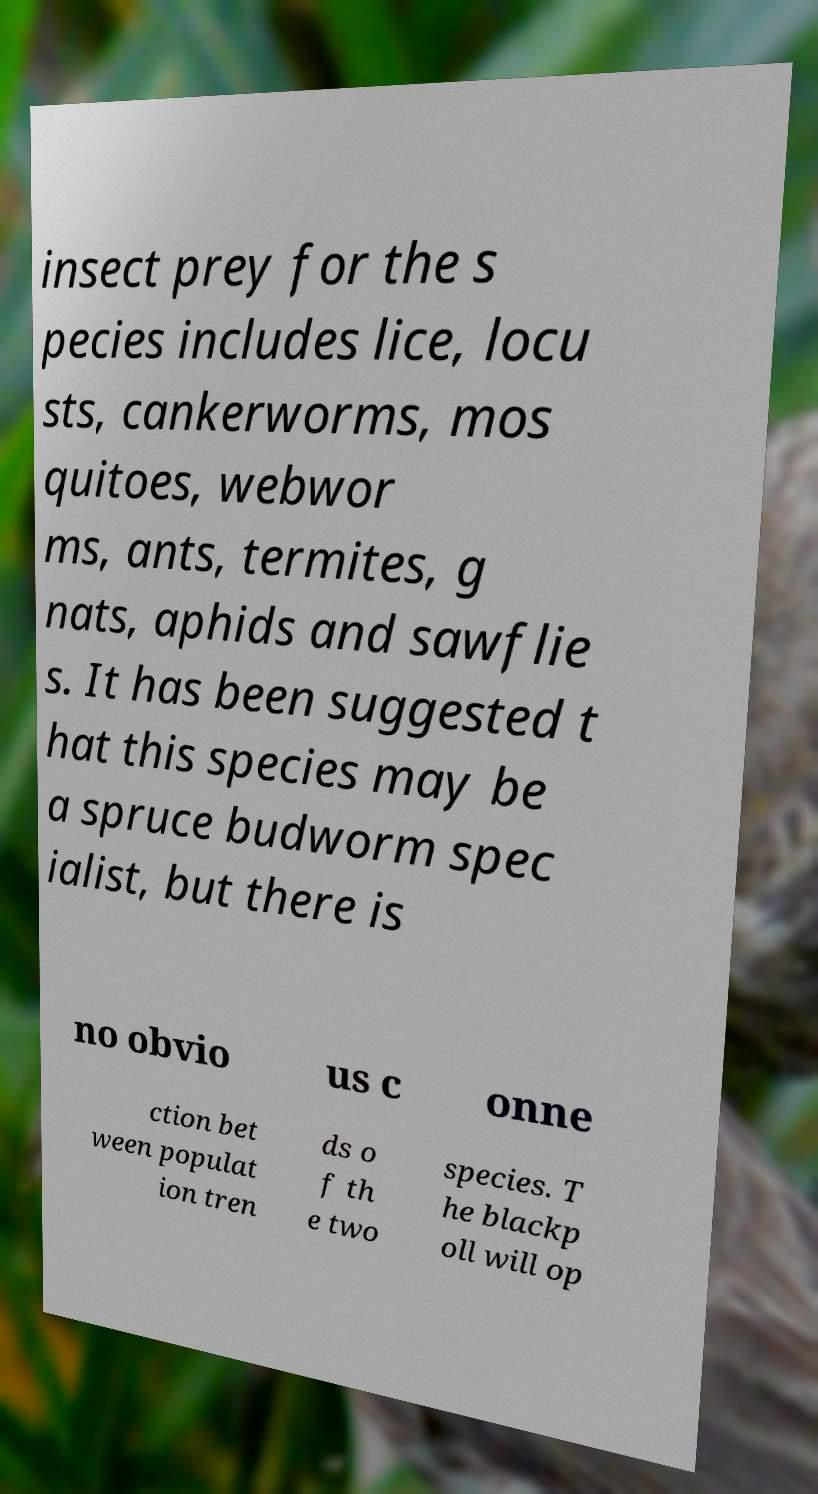I need the written content from this picture converted into text. Can you do that? insect prey for the s pecies includes lice, locu sts, cankerworms, mos quitoes, webwor ms, ants, termites, g nats, aphids and sawflie s. It has been suggested t hat this species may be a spruce budworm spec ialist, but there is no obvio us c onne ction bet ween populat ion tren ds o f th e two species. T he blackp oll will op 